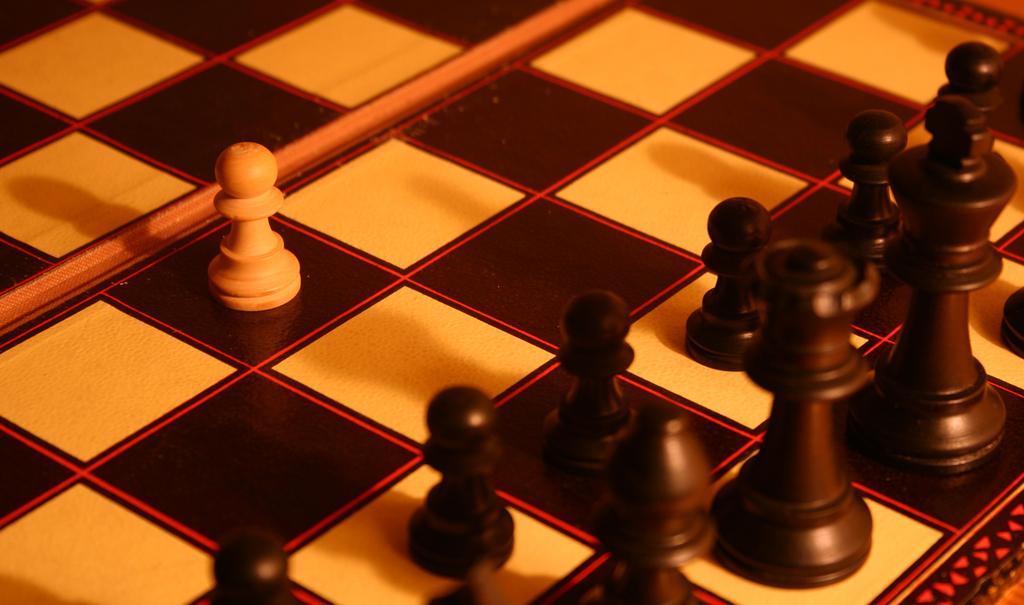In one or two sentences, can you explain what this image depicts? In this image we can see there is a chess board with chess pieces. 